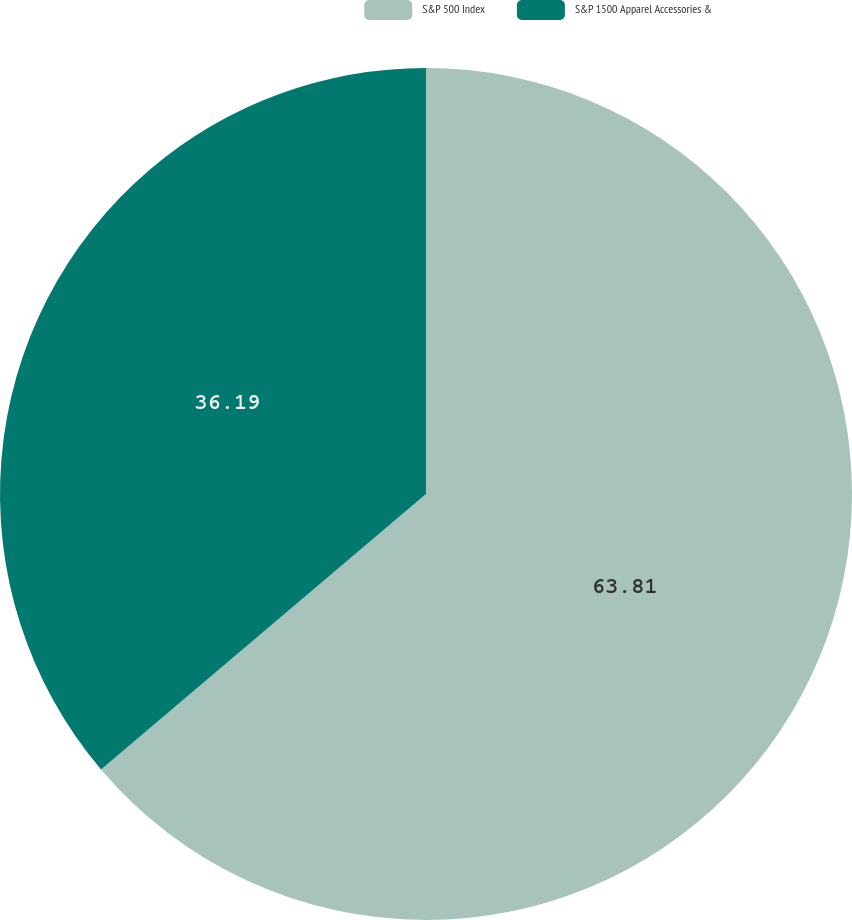Convert chart. <chart><loc_0><loc_0><loc_500><loc_500><pie_chart><fcel>S&P 500 Index<fcel>S&P 1500 Apparel Accessories &<nl><fcel>63.81%<fcel>36.19%<nl></chart> 